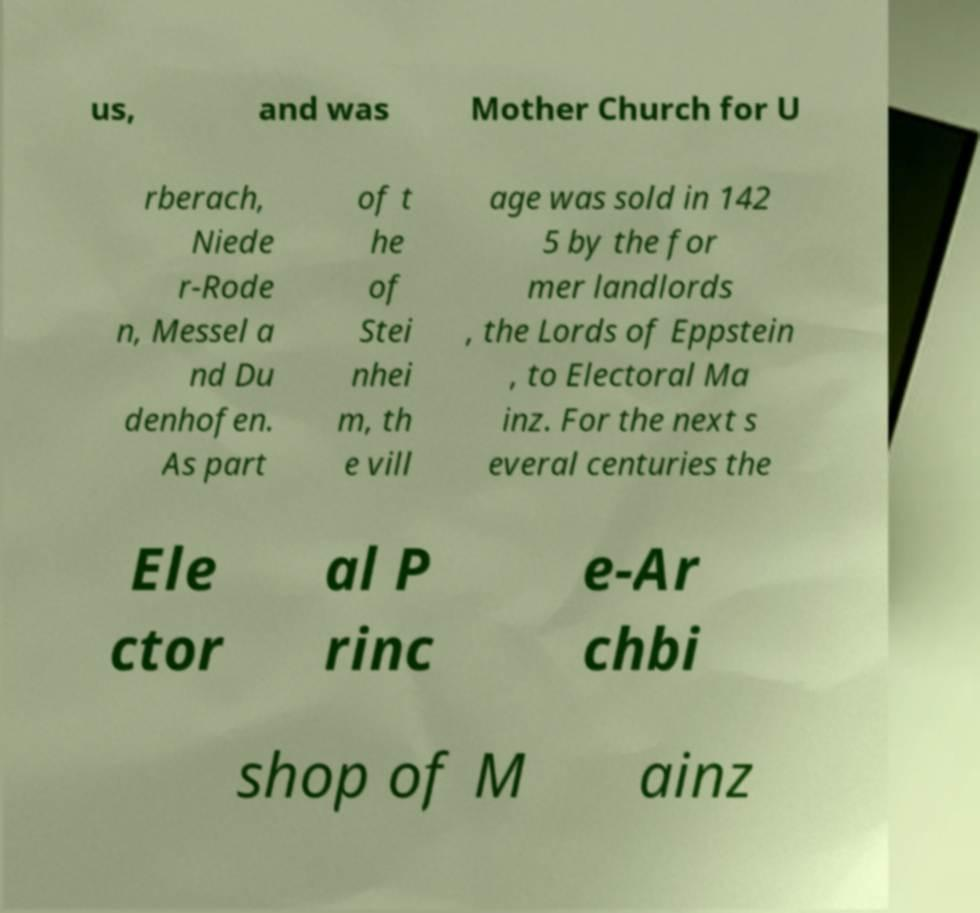Could you extract and type out the text from this image? us, and was Mother Church for U rberach, Niede r-Rode n, Messel a nd Du denhofen. As part of t he of Stei nhei m, th e vill age was sold in 142 5 by the for mer landlords , the Lords of Eppstein , to Electoral Ma inz. For the next s everal centuries the Ele ctor al P rinc e-Ar chbi shop of M ainz 